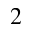<formula> <loc_0><loc_0><loc_500><loc_500>_ { 2 }</formula> 